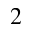<formula> <loc_0><loc_0><loc_500><loc_500>_ { 2 }</formula> 